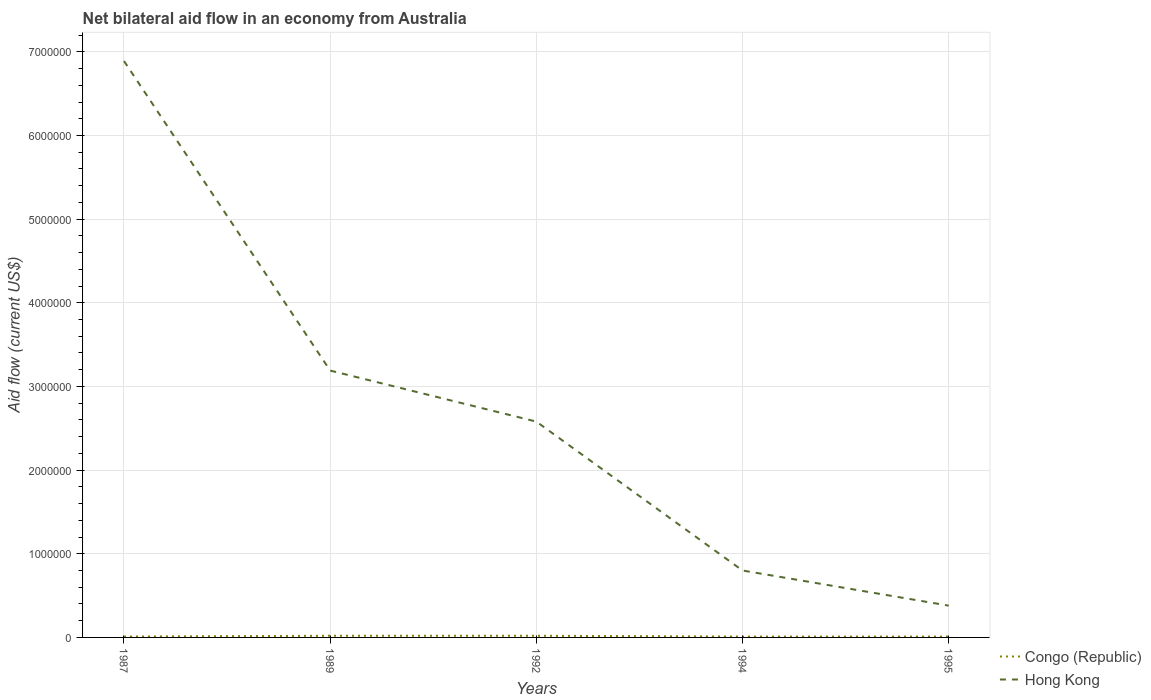How many different coloured lines are there?
Your response must be concise. 2. What is the total net bilateral aid flow in Congo (Republic) in the graph?
Offer a very short reply. 0. What is the difference between the highest and the second highest net bilateral aid flow in Congo (Republic)?
Offer a very short reply. 10000. Is the net bilateral aid flow in Hong Kong strictly greater than the net bilateral aid flow in Congo (Republic) over the years?
Your answer should be compact. No. What is the difference between two consecutive major ticks on the Y-axis?
Make the answer very short. 1.00e+06. Are the values on the major ticks of Y-axis written in scientific E-notation?
Your answer should be very brief. No. Does the graph contain any zero values?
Offer a very short reply. No. Where does the legend appear in the graph?
Give a very brief answer. Bottom right. What is the title of the graph?
Provide a short and direct response. Net bilateral aid flow in an economy from Australia. Does "Guam" appear as one of the legend labels in the graph?
Provide a succinct answer. No. What is the Aid flow (current US$) of Congo (Republic) in 1987?
Your answer should be very brief. 10000. What is the Aid flow (current US$) of Hong Kong in 1987?
Your answer should be very brief. 6.89e+06. What is the Aid flow (current US$) in Congo (Republic) in 1989?
Offer a terse response. 2.00e+04. What is the Aid flow (current US$) of Hong Kong in 1989?
Provide a succinct answer. 3.19e+06. What is the Aid flow (current US$) in Congo (Republic) in 1992?
Your answer should be compact. 2.00e+04. What is the Aid flow (current US$) in Hong Kong in 1992?
Make the answer very short. 2.58e+06. What is the Aid flow (current US$) of Congo (Republic) in 1994?
Ensure brevity in your answer.  10000. Across all years, what is the maximum Aid flow (current US$) of Congo (Republic)?
Your answer should be compact. 2.00e+04. Across all years, what is the maximum Aid flow (current US$) of Hong Kong?
Your answer should be compact. 6.89e+06. What is the total Aid flow (current US$) in Congo (Republic) in the graph?
Your response must be concise. 7.00e+04. What is the total Aid flow (current US$) in Hong Kong in the graph?
Ensure brevity in your answer.  1.38e+07. What is the difference between the Aid flow (current US$) in Congo (Republic) in 1987 and that in 1989?
Make the answer very short. -10000. What is the difference between the Aid flow (current US$) in Hong Kong in 1987 and that in 1989?
Offer a very short reply. 3.70e+06. What is the difference between the Aid flow (current US$) in Congo (Republic) in 1987 and that in 1992?
Your answer should be very brief. -10000. What is the difference between the Aid flow (current US$) in Hong Kong in 1987 and that in 1992?
Offer a terse response. 4.31e+06. What is the difference between the Aid flow (current US$) of Congo (Republic) in 1987 and that in 1994?
Ensure brevity in your answer.  0. What is the difference between the Aid flow (current US$) in Hong Kong in 1987 and that in 1994?
Your response must be concise. 6.09e+06. What is the difference between the Aid flow (current US$) of Congo (Republic) in 1987 and that in 1995?
Give a very brief answer. 0. What is the difference between the Aid flow (current US$) of Hong Kong in 1987 and that in 1995?
Ensure brevity in your answer.  6.51e+06. What is the difference between the Aid flow (current US$) in Hong Kong in 1989 and that in 1992?
Give a very brief answer. 6.10e+05. What is the difference between the Aid flow (current US$) in Congo (Republic) in 1989 and that in 1994?
Offer a terse response. 10000. What is the difference between the Aid flow (current US$) of Hong Kong in 1989 and that in 1994?
Offer a very short reply. 2.39e+06. What is the difference between the Aid flow (current US$) of Hong Kong in 1989 and that in 1995?
Give a very brief answer. 2.81e+06. What is the difference between the Aid flow (current US$) of Hong Kong in 1992 and that in 1994?
Keep it short and to the point. 1.78e+06. What is the difference between the Aid flow (current US$) in Hong Kong in 1992 and that in 1995?
Provide a succinct answer. 2.20e+06. What is the difference between the Aid flow (current US$) in Congo (Republic) in 1987 and the Aid flow (current US$) in Hong Kong in 1989?
Offer a very short reply. -3.18e+06. What is the difference between the Aid flow (current US$) in Congo (Republic) in 1987 and the Aid flow (current US$) in Hong Kong in 1992?
Your response must be concise. -2.57e+06. What is the difference between the Aid flow (current US$) in Congo (Republic) in 1987 and the Aid flow (current US$) in Hong Kong in 1994?
Your answer should be compact. -7.90e+05. What is the difference between the Aid flow (current US$) in Congo (Republic) in 1987 and the Aid flow (current US$) in Hong Kong in 1995?
Your response must be concise. -3.70e+05. What is the difference between the Aid flow (current US$) in Congo (Republic) in 1989 and the Aid flow (current US$) in Hong Kong in 1992?
Ensure brevity in your answer.  -2.56e+06. What is the difference between the Aid flow (current US$) of Congo (Republic) in 1989 and the Aid flow (current US$) of Hong Kong in 1994?
Offer a terse response. -7.80e+05. What is the difference between the Aid flow (current US$) in Congo (Republic) in 1989 and the Aid flow (current US$) in Hong Kong in 1995?
Your answer should be very brief. -3.60e+05. What is the difference between the Aid flow (current US$) in Congo (Republic) in 1992 and the Aid flow (current US$) in Hong Kong in 1994?
Offer a terse response. -7.80e+05. What is the difference between the Aid flow (current US$) of Congo (Republic) in 1992 and the Aid flow (current US$) of Hong Kong in 1995?
Offer a terse response. -3.60e+05. What is the difference between the Aid flow (current US$) of Congo (Republic) in 1994 and the Aid flow (current US$) of Hong Kong in 1995?
Your answer should be very brief. -3.70e+05. What is the average Aid flow (current US$) in Congo (Republic) per year?
Your answer should be very brief. 1.40e+04. What is the average Aid flow (current US$) in Hong Kong per year?
Your response must be concise. 2.77e+06. In the year 1987, what is the difference between the Aid flow (current US$) of Congo (Republic) and Aid flow (current US$) of Hong Kong?
Your response must be concise. -6.88e+06. In the year 1989, what is the difference between the Aid flow (current US$) in Congo (Republic) and Aid flow (current US$) in Hong Kong?
Your answer should be very brief. -3.17e+06. In the year 1992, what is the difference between the Aid flow (current US$) in Congo (Republic) and Aid flow (current US$) in Hong Kong?
Give a very brief answer. -2.56e+06. In the year 1994, what is the difference between the Aid flow (current US$) of Congo (Republic) and Aid flow (current US$) of Hong Kong?
Offer a terse response. -7.90e+05. In the year 1995, what is the difference between the Aid flow (current US$) in Congo (Republic) and Aid flow (current US$) in Hong Kong?
Offer a very short reply. -3.70e+05. What is the ratio of the Aid flow (current US$) of Hong Kong in 1987 to that in 1989?
Offer a terse response. 2.16. What is the ratio of the Aid flow (current US$) of Congo (Republic) in 1987 to that in 1992?
Your answer should be compact. 0.5. What is the ratio of the Aid flow (current US$) in Hong Kong in 1987 to that in 1992?
Your answer should be compact. 2.67. What is the ratio of the Aid flow (current US$) in Congo (Republic) in 1987 to that in 1994?
Keep it short and to the point. 1. What is the ratio of the Aid flow (current US$) in Hong Kong in 1987 to that in 1994?
Provide a succinct answer. 8.61. What is the ratio of the Aid flow (current US$) of Congo (Republic) in 1987 to that in 1995?
Provide a short and direct response. 1. What is the ratio of the Aid flow (current US$) in Hong Kong in 1987 to that in 1995?
Your answer should be very brief. 18.13. What is the ratio of the Aid flow (current US$) of Congo (Republic) in 1989 to that in 1992?
Provide a short and direct response. 1. What is the ratio of the Aid flow (current US$) of Hong Kong in 1989 to that in 1992?
Offer a terse response. 1.24. What is the ratio of the Aid flow (current US$) in Congo (Republic) in 1989 to that in 1994?
Make the answer very short. 2. What is the ratio of the Aid flow (current US$) of Hong Kong in 1989 to that in 1994?
Provide a short and direct response. 3.99. What is the ratio of the Aid flow (current US$) of Hong Kong in 1989 to that in 1995?
Make the answer very short. 8.39. What is the ratio of the Aid flow (current US$) in Congo (Republic) in 1992 to that in 1994?
Make the answer very short. 2. What is the ratio of the Aid flow (current US$) in Hong Kong in 1992 to that in 1994?
Offer a terse response. 3.23. What is the ratio of the Aid flow (current US$) of Hong Kong in 1992 to that in 1995?
Make the answer very short. 6.79. What is the ratio of the Aid flow (current US$) in Congo (Republic) in 1994 to that in 1995?
Offer a terse response. 1. What is the ratio of the Aid flow (current US$) of Hong Kong in 1994 to that in 1995?
Ensure brevity in your answer.  2.11. What is the difference between the highest and the second highest Aid flow (current US$) of Congo (Republic)?
Your answer should be compact. 0. What is the difference between the highest and the second highest Aid flow (current US$) of Hong Kong?
Offer a very short reply. 3.70e+06. What is the difference between the highest and the lowest Aid flow (current US$) in Congo (Republic)?
Your response must be concise. 10000. What is the difference between the highest and the lowest Aid flow (current US$) in Hong Kong?
Your answer should be compact. 6.51e+06. 